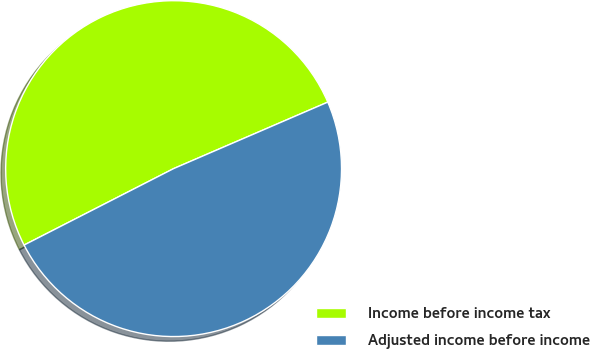Convert chart to OTSL. <chart><loc_0><loc_0><loc_500><loc_500><pie_chart><fcel>Income before income tax<fcel>Adjusted income before income<nl><fcel>51.04%<fcel>48.96%<nl></chart> 